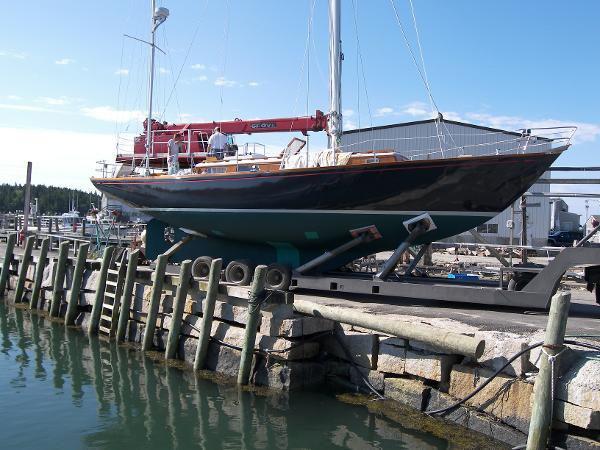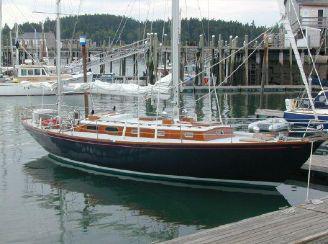The first image is the image on the left, the second image is the image on the right. For the images shown, is this caption "One of the images contains a single sailboat with three sails" true? Answer yes or no. No. 